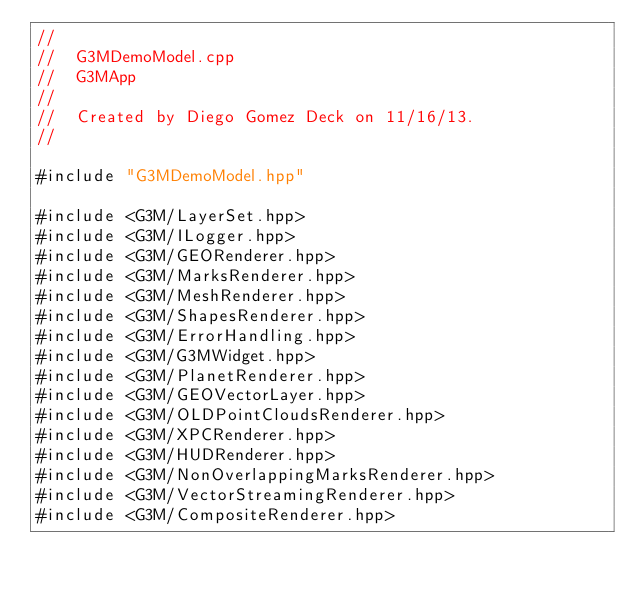Convert code to text. <code><loc_0><loc_0><loc_500><loc_500><_ObjectiveC_>//
//  G3MDemoModel.cpp
//  G3MApp
//
//  Created by Diego Gomez Deck on 11/16/13.
//

#include "G3MDemoModel.hpp"

#include <G3M/LayerSet.hpp>
#include <G3M/ILogger.hpp>
#include <G3M/GEORenderer.hpp>
#include <G3M/MarksRenderer.hpp>
#include <G3M/MeshRenderer.hpp>
#include <G3M/ShapesRenderer.hpp>
#include <G3M/ErrorHandling.hpp>
#include <G3M/G3MWidget.hpp>
#include <G3M/PlanetRenderer.hpp>
#include <G3M/GEOVectorLayer.hpp>
#include <G3M/OLDPointCloudsRenderer.hpp>
#include <G3M/XPCRenderer.hpp>
#include <G3M/HUDRenderer.hpp>
#include <G3M/NonOverlappingMarksRenderer.hpp>
#include <G3M/VectorStreamingRenderer.hpp>
#include <G3M/CompositeRenderer.hpp></code> 